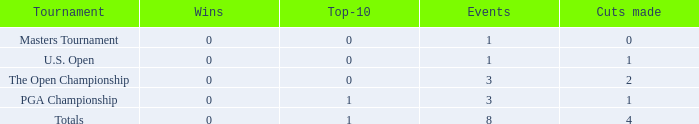For more than 3 events in the PGA Championship, what is the fewest number of wins? None. 